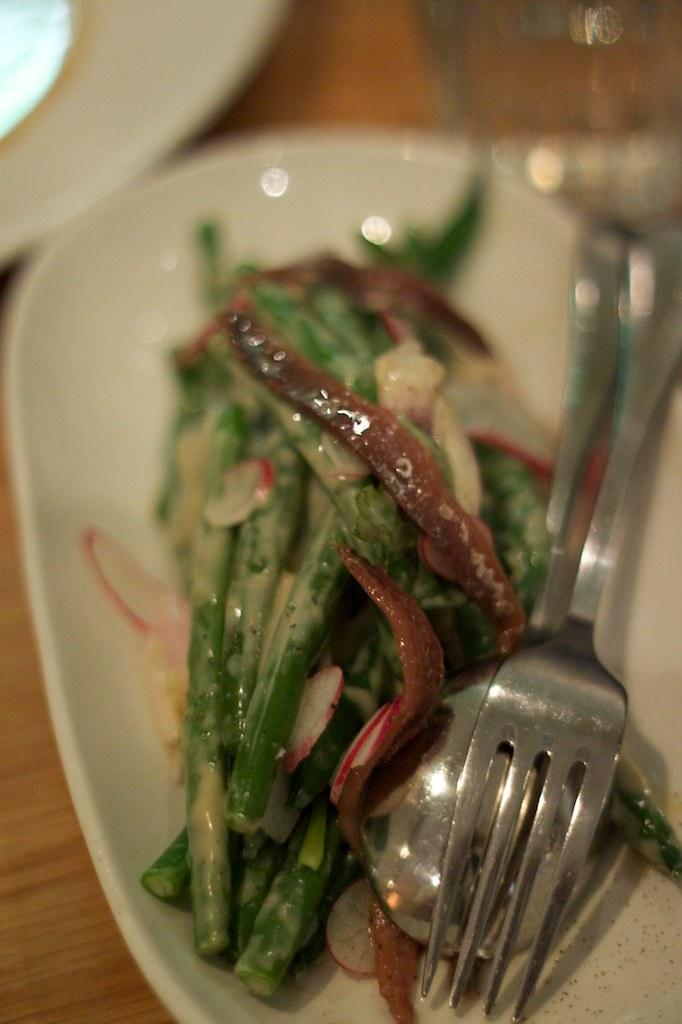What utensils are present in the image? There is a fork and a spoon in the image. What can be seen on the plate in the image? There are food items on a white color plate in the image. How many birds are sitting on the plate in the image? There are no birds present on the plate in the image. 